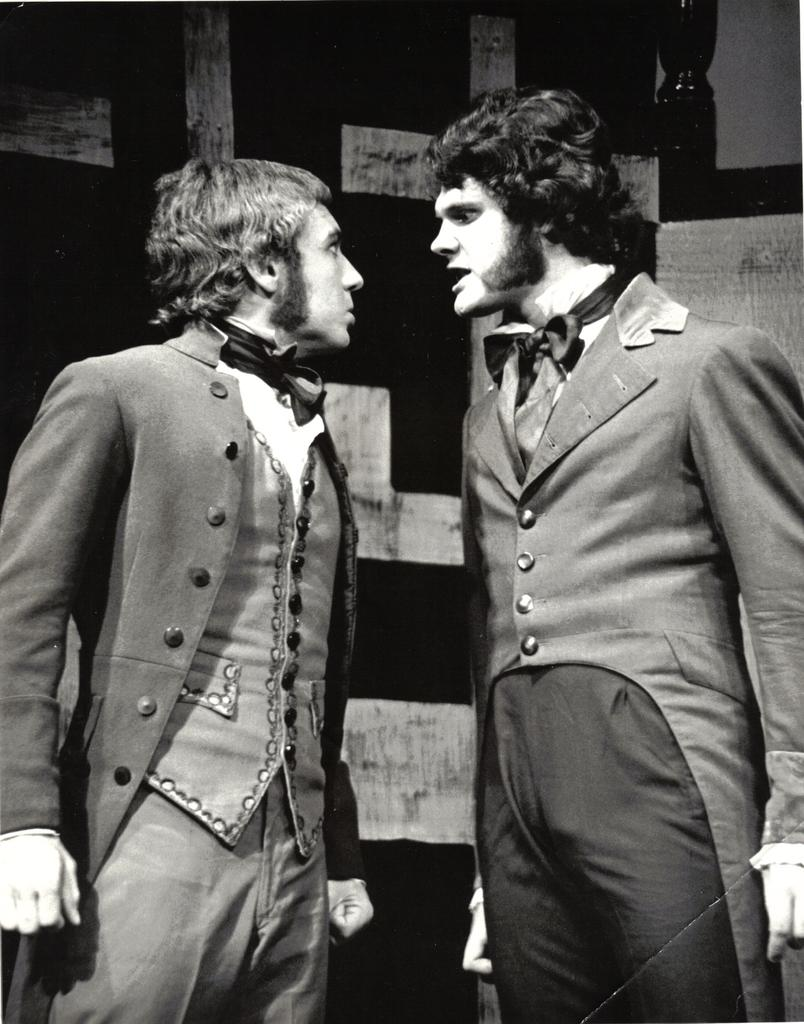How many people are present in the image? There are two people standing in the image. What are the people wearing? The people are wearing jackets. What can be seen in the background of the image? There is a wall in the background of the image. What type of shirt is the pet wearing in the image? There is no pet present in the image, and therefore no shirt or pet can be observed. 